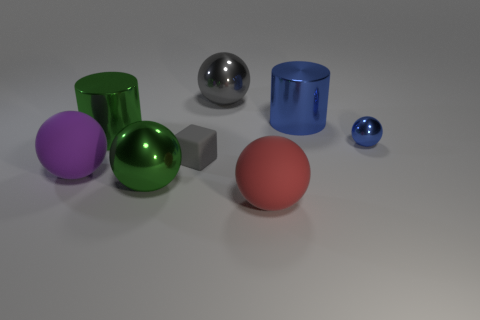What is the material of the big sphere in front of the green metallic sphere?
Offer a very short reply. Rubber. What number of small objects are either blue cylinders or purple shiny blocks?
Your response must be concise. 0. There is a large cylinder that is the same color as the tiny shiny object; what material is it?
Provide a short and direct response. Metal. Are there any tiny blue things made of the same material as the purple sphere?
Provide a short and direct response. No. There is a matte thing to the left of the block; is its size the same as the big red rubber thing?
Provide a short and direct response. Yes. There is a blue shiny thing that is in front of the big green object that is behind the purple sphere; is there a gray rubber cube in front of it?
Offer a terse response. Yes. How many shiny things are gray balls or cyan cylinders?
Offer a very short reply. 1. What number of other objects are the same shape as the tiny blue metallic thing?
Your response must be concise. 4. Are there more large red shiny objects than big gray shiny spheres?
Give a very brief answer. No. What size is the metal thing that is on the left side of the green metal object that is in front of the gray thing in front of the large gray ball?
Keep it short and to the point. Large. 